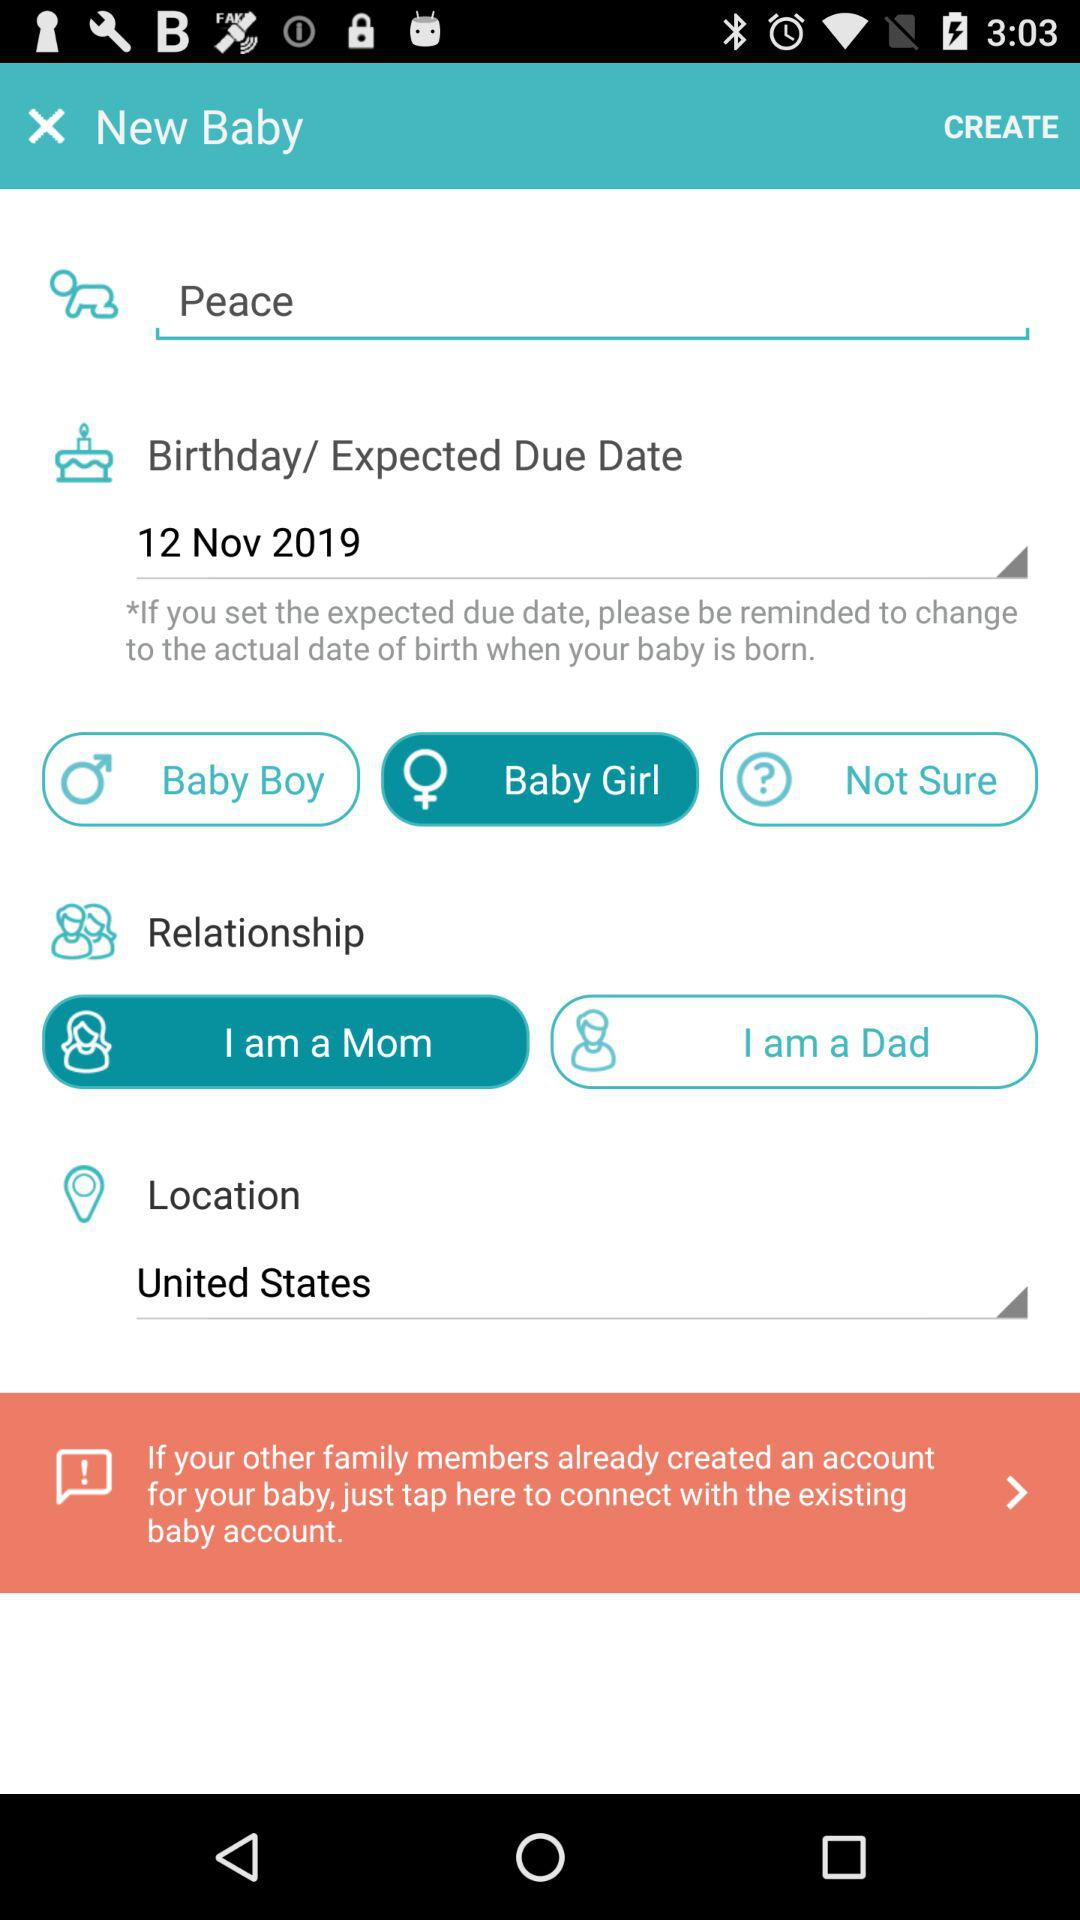What is the gender? The gender is "Baby Girl". 